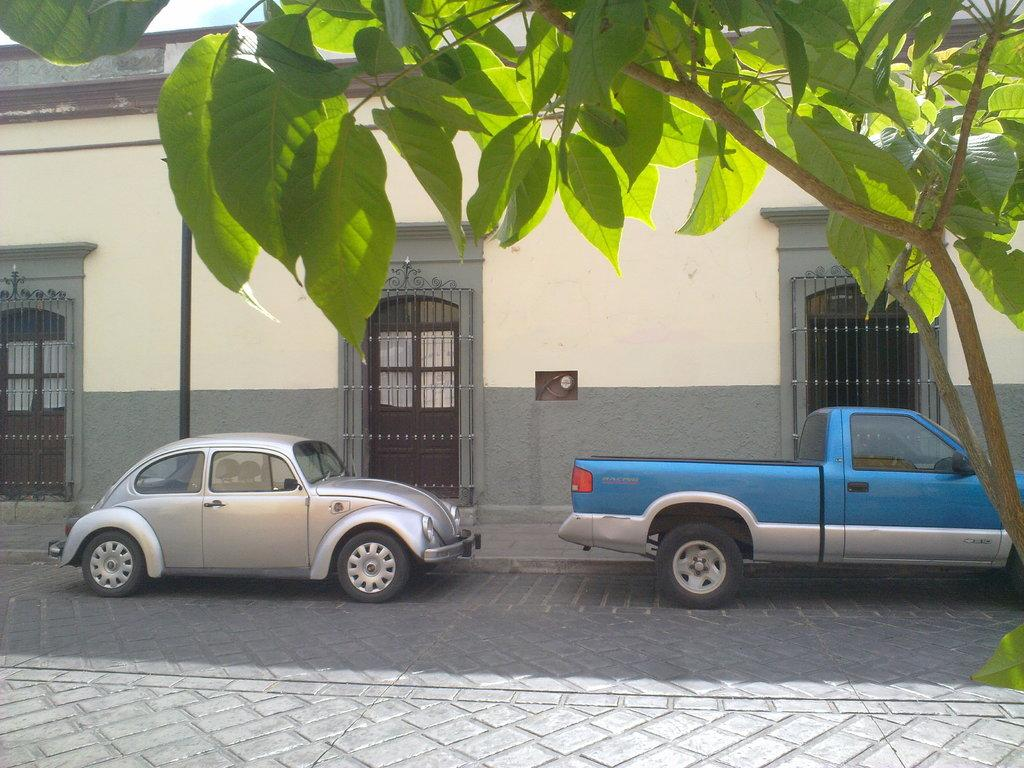How many cars are on the road in the image? There are two cars on the road in the image. What type of vegetation can be seen in the image? There is a tree visible in the image. What type of structure is present in the image? There is a house in the image. What part of the house is visible in the image? There are doors in the image. What is visible at the top of the image? The sky is visible in the image. How many dogs are visible in the image? There are no dogs present in the image. What type of glove is being worn by the person in the image? There is no person or glove present in the image. What time of day is it in the image? The time of day is not specified in the image. 